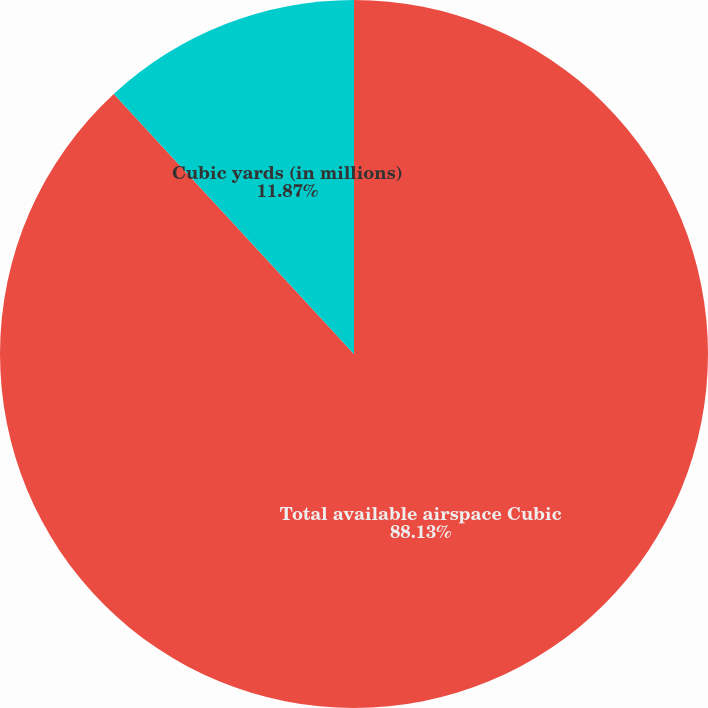Convert chart to OTSL. <chart><loc_0><loc_0><loc_500><loc_500><pie_chart><fcel>Total available airspace Cubic<fcel>Cubic yards (in millions)<nl><fcel>88.13%<fcel>11.87%<nl></chart> 